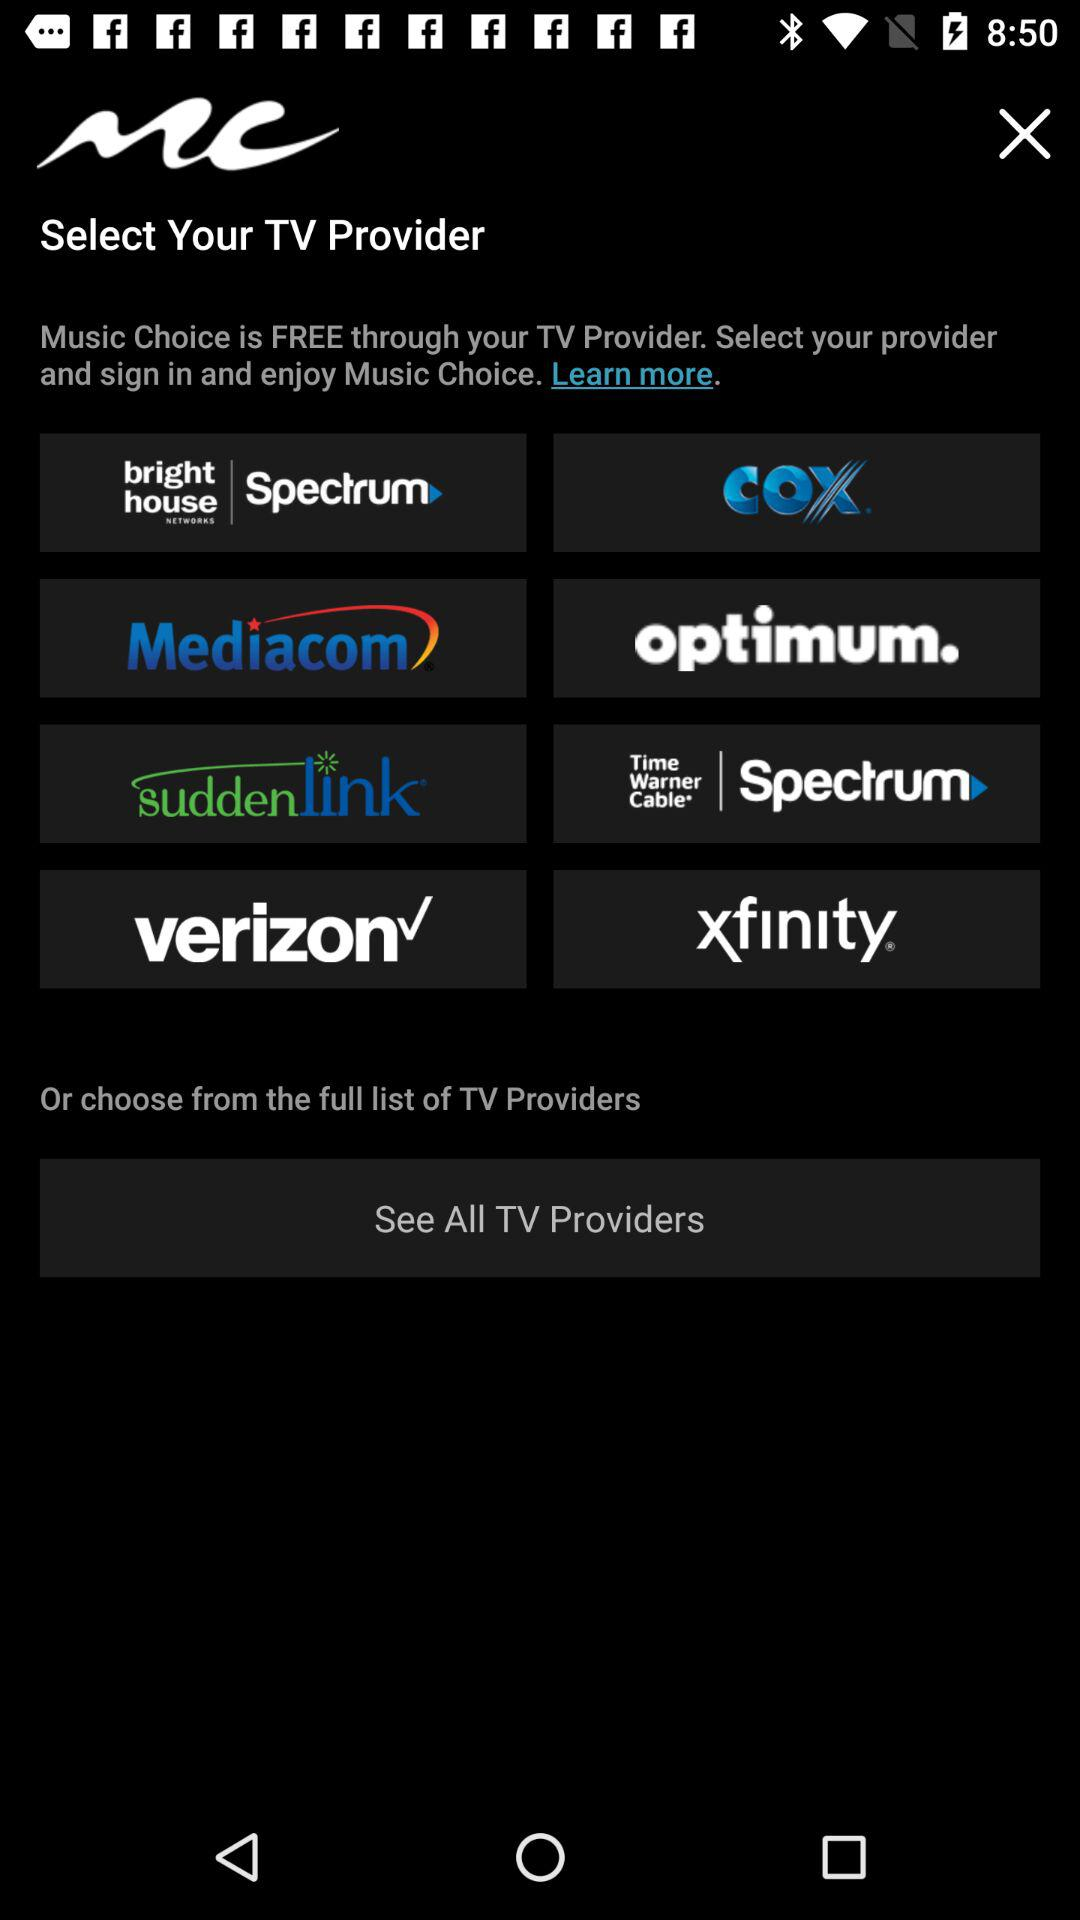How many TV providers are available?
Answer the question using a single word or phrase. 8 